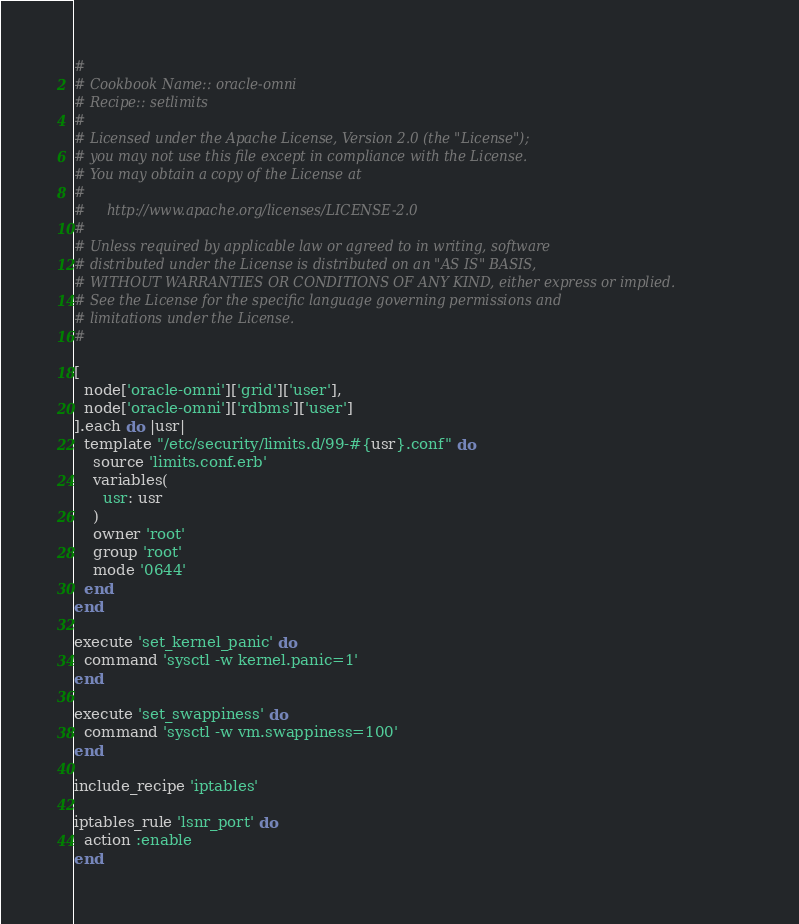Convert code to text. <code><loc_0><loc_0><loc_500><loc_500><_Ruby_>#
# Cookbook Name:: oracle-omni
# Recipe:: setlimits
#
# Licensed under the Apache License, Version 2.0 (the "License");
# you may not use this file except in compliance with the License.
# You may obtain a copy of the License at
#
#     http://www.apache.org/licenses/LICENSE-2.0
#
# Unless required by applicable law or agreed to in writing, software
# distributed under the License is distributed on an "AS IS" BASIS,
# WITHOUT WARRANTIES OR CONDITIONS OF ANY KIND, either express or implied.
# See the License for the specific language governing permissions and
# limitations under the License.
#

[
  node['oracle-omni']['grid']['user'],
  node['oracle-omni']['rdbms']['user']
].each do |usr|
  template "/etc/security/limits.d/99-#{usr}.conf" do
    source 'limits.conf.erb'
    variables(
      usr: usr
    )
    owner 'root'
    group 'root'
    mode '0644'
  end
end

execute 'set_kernel_panic' do
  command 'sysctl -w kernel.panic=1'
end

execute 'set_swappiness' do
  command 'sysctl -w vm.swappiness=100'
end

include_recipe 'iptables'

iptables_rule 'lsnr_port' do
  action :enable
end
</code> 